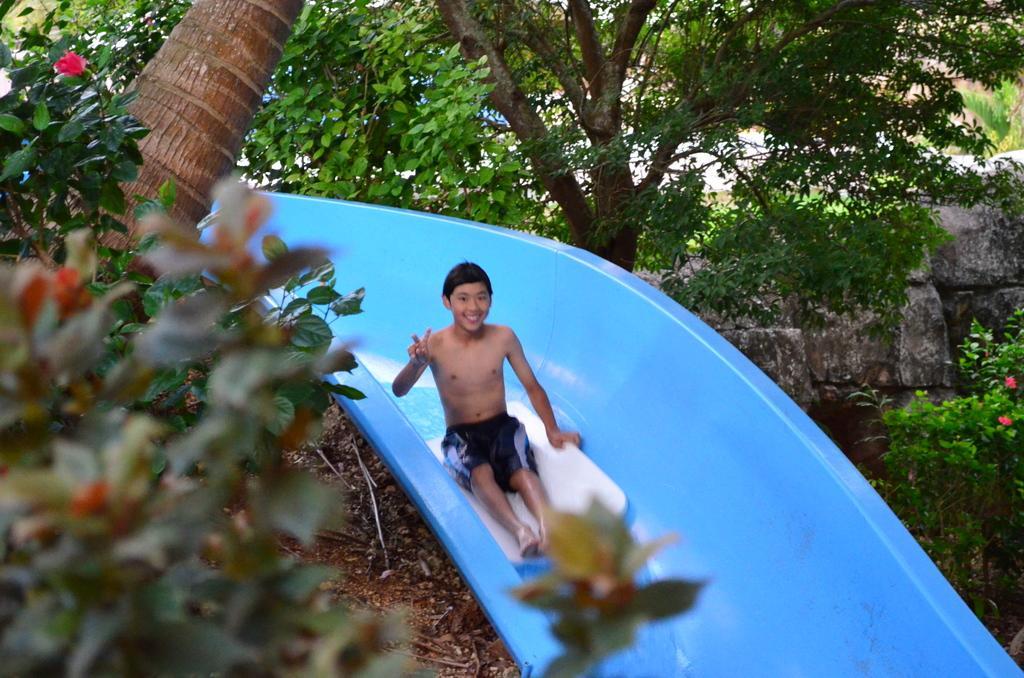Could you give a brief overview of what you see in this image? This is the picture of a boy who is coming through the plastic tube and around him there are some plants. 